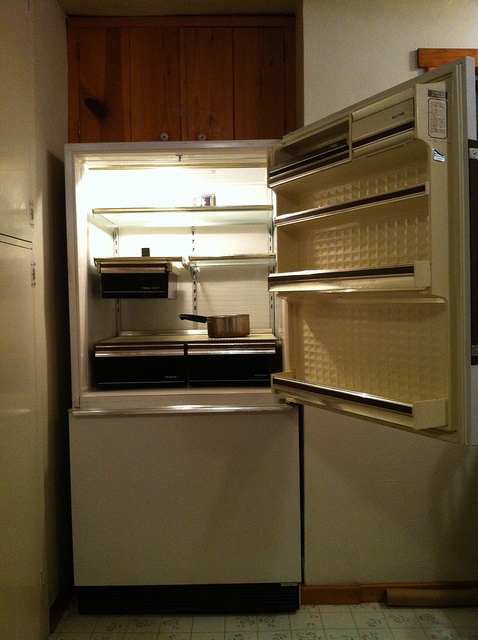Describe the objects in this image and their specific colors. I can see a refrigerator in maroon, olive, black, and ivory tones in this image. 